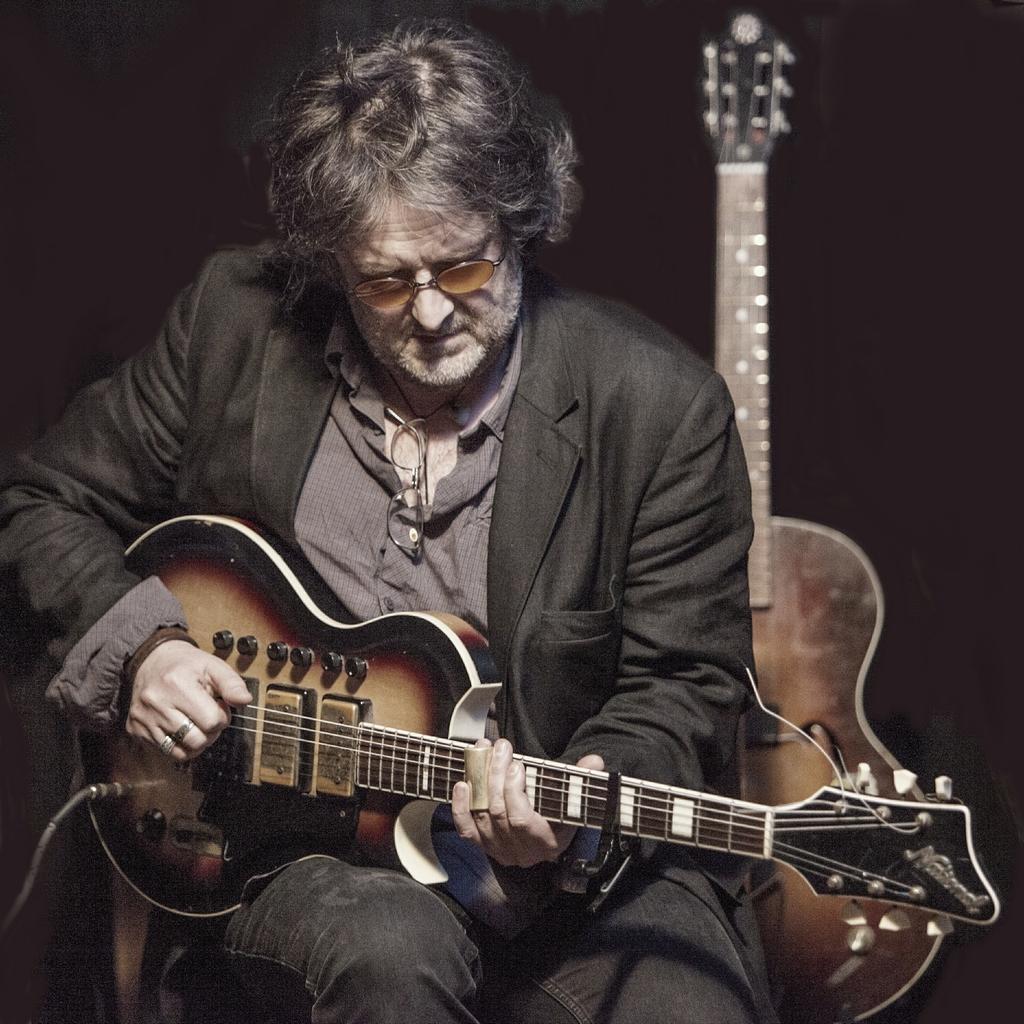How would you summarize this image in a sentence or two? In this image I can see a man wearing black color suit sitting on the chair and playing the guitar. At the back of this person there is another guitar is placed. 